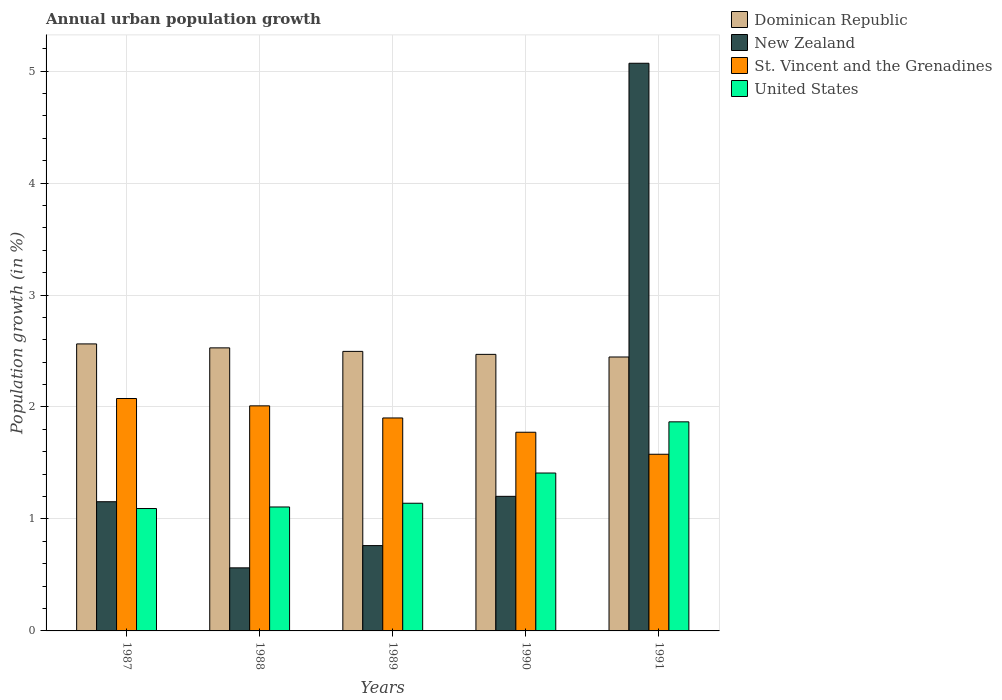How many different coloured bars are there?
Make the answer very short. 4. Are the number of bars per tick equal to the number of legend labels?
Your answer should be very brief. Yes. How many bars are there on the 4th tick from the right?
Your answer should be compact. 4. What is the label of the 2nd group of bars from the left?
Give a very brief answer. 1988. In how many cases, is the number of bars for a given year not equal to the number of legend labels?
Keep it short and to the point. 0. What is the percentage of urban population growth in New Zealand in 1989?
Offer a very short reply. 0.76. Across all years, what is the maximum percentage of urban population growth in Dominican Republic?
Provide a succinct answer. 2.56. Across all years, what is the minimum percentage of urban population growth in United States?
Provide a succinct answer. 1.09. What is the total percentage of urban population growth in Dominican Republic in the graph?
Provide a succinct answer. 12.51. What is the difference between the percentage of urban population growth in St. Vincent and the Grenadines in 1988 and that in 1990?
Ensure brevity in your answer.  0.24. What is the difference between the percentage of urban population growth in St. Vincent and the Grenadines in 1987 and the percentage of urban population growth in United States in 1991?
Offer a very short reply. 0.21. What is the average percentage of urban population growth in Dominican Republic per year?
Make the answer very short. 2.5. In the year 1988, what is the difference between the percentage of urban population growth in Dominican Republic and percentage of urban population growth in St. Vincent and the Grenadines?
Make the answer very short. 0.52. In how many years, is the percentage of urban population growth in New Zealand greater than 5 %?
Your response must be concise. 1. What is the ratio of the percentage of urban population growth in United States in 1988 to that in 1991?
Your response must be concise. 0.59. Is the difference between the percentage of urban population growth in Dominican Republic in 1988 and 1990 greater than the difference between the percentage of urban population growth in St. Vincent and the Grenadines in 1988 and 1990?
Offer a terse response. No. What is the difference between the highest and the second highest percentage of urban population growth in Dominican Republic?
Make the answer very short. 0.04. What is the difference between the highest and the lowest percentage of urban population growth in Dominican Republic?
Your answer should be compact. 0.12. In how many years, is the percentage of urban population growth in New Zealand greater than the average percentage of urban population growth in New Zealand taken over all years?
Your answer should be very brief. 1. What does the 3rd bar from the left in 1990 represents?
Give a very brief answer. St. Vincent and the Grenadines. What does the 2nd bar from the right in 1987 represents?
Your answer should be compact. St. Vincent and the Grenadines. Is it the case that in every year, the sum of the percentage of urban population growth in St. Vincent and the Grenadines and percentage of urban population growth in New Zealand is greater than the percentage of urban population growth in United States?
Make the answer very short. Yes. How many years are there in the graph?
Offer a very short reply. 5. Are the values on the major ticks of Y-axis written in scientific E-notation?
Your answer should be very brief. No. How are the legend labels stacked?
Provide a succinct answer. Vertical. What is the title of the graph?
Offer a very short reply. Annual urban population growth. What is the label or title of the X-axis?
Your response must be concise. Years. What is the label or title of the Y-axis?
Ensure brevity in your answer.  Population growth (in %). What is the Population growth (in %) of Dominican Republic in 1987?
Your answer should be very brief. 2.56. What is the Population growth (in %) of New Zealand in 1987?
Your answer should be very brief. 1.15. What is the Population growth (in %) of St. Vincent and the Grenadines in 1987?
Make the answer very short. 2.08. What is the Population growth (in %) of United States in 1987?
Give a very brief answer. 1.09. What is the Population growth (in %) of Dominican Republic in 1988?
Offer a very short reply. 2.53. What is the Population growth (in %) in New Zealand in 1988?
Make the answer very short. 0.56. What is the Population growth (in %) of St. Vincent and the Grenadines in 1988?
Make the answer very short. 2.01. What is the Population growth (in %) in United States in 1988?
Give a very brief answer. 1.11. What is the Population growth (in %) in Dominican Republic in 1989?
Make the answer very short. 2.5. What is the Population growth (in %) in New Zealand in 1989?
Ensure brevity in your answer.  0.76. What is the Population growth (in %) of St. Vincent and the Grenadines in 1989?
Ensure brevity in your answer.  1.9. What is the Population growth (in %) of United States in 1989?
Give a very brief answer. 1.14. What is the Population growth (in %) in Dominican Republic in 1990?
Offer a very short reply. 2.47. What is the Population growth (in %) of New Zealand in 1990?
Offer a very short reply. 1.2. What is the Population growth (in %) of St. Vincent and the Grenadines in 1990?
Offer a very short reply. 1.77. What is the Population growth (in %) of United States in 1990?
Provide a short and direct response. 1.41. What is the Population growth (in %) of Dominican Republic in 1991?
Give a very brief answer. 2.45. What is the Population growth (in %) in New Zealand in 1991?
Provide a succinct answer. 5.07. What is the Population growth (in %) of St. Vincent and the Grenadines in 1991?
Provide a succinct answer. 1.58. What is the Population growth (in %) in United States in 1991?
Offer a very short reply. 1.87. Across all years, what is the maximum Population growth (in %) of Dominican Republic?
Provide a succinct answer. 2.56. Across all years, what is the maximum Population growth (in %) of New Zealand?
Provide a short and direct response. 5.07. Across all years, what is the maximum Population growth (in %) of St. Vincent and the Grenadines?
Your response must be concise. 2.08. Across all years, what is the maximum Population growth (in %) of United States?
Offer a very short reply. 1.87. Across all years, what is the minimum Population growth (in %) in Dominican Republic?
Make the answer very short. 2.45. Across all years, what is the minimum Population growth (in %) of New Zealand?
Offer a terse response. 0.56. Across all years, what is the minimum Population growth (in %) in St. Vincent and the Grenadines?
Make the answer very short. 1.58. Across all years, what is the minimum Population growth (in %) in United States?
Give a very brief answer. 1.09. What is the total Population growth (in %) of Dominican Republic in the graph?
Offer a terse response. 12.51. What is the total Population growth (in %) of New Zealand in the graph?
Provide a succinct answer. 8.75. What is the total Population growth (in %) in St. Vincent and the Grenadines in the graph?
Ensure brevity in your answer.  9.34. What is the total Population growth (in %) of United States in the graph?
Make the answer very short. 6.62. What is the difference between the Population growth (in %) of Dominican Republic in 1987 and that in 1988?
Offer a very short reply. 0.04. What is the difference between the Population growth (in %) of New Zealand in 1987 and that in 1988?
Make the answer very short. 0.59. What is the difference between the Population growth (in %) of St. Vincent and the Grenadines in 1987 and that in 1988?
Offer a very short reply. 0.07. What is the difference between the Population growth (in %) in United States in 1987 and that in 1988?
Your response must be concise. -0.01. What is the difference between the Population growth (in %) of Dominican Republic in 1987 and that in 1989?
Offer a very short reply. 0.07. What is the difference between the Population growth (in %) of New Zealand in 1987 and that in 1989?
Offer a very short reply. 0.39. What is the difference between the Population growth (in %) in St. Vincent and the Grenadines in 1987 and that in 1989?
Offer a terse response. 0.17. What is the difference between the Population growth (in %) of United States in 1987 and that in 1989?
Provide a succinct answer. -0.05. What is the difference between the Population growth (in %) of Dominican Republic in 1987 and that in 1990?
Provide a succinct answer. 0.09. What is the difference between the Population growth (in %) in New Zealand in 1987 and that in 1990?
Keep it short and to the point. -0.05. What is the difference between the Population growth (in %) in St. Vincent and the Grenadines in 1987 and that in 1990?
Offer a very short reply. 0.3. What is the difference between the Population growth (in %) in United States in 1987 and that in 1990?
Provide a succinct answer. -0.32. What is the difference between the Population growth (in %) in Dominican Republic in 1987 and that in 1991?
Provide a short and direct response. 0.12. What is the difference between the Population growth (in %) in New Zealand in 1987 and that in 1991?
Keep it short and to the point. -3.92. What is the difference between the Population growth (in %) of St. Vincent and the Grenadines in 1987 and that in 1991?
Your answer should be compact. 0.5. What is the difference between the Population growth (in %) in United States in 1987 and that in 1991?
Keep it short and to the point. -0.77. What is the difference between the Population growth (in %) in Dominican Republic in 1988 and that in 1989?
Keep it short and to the point. 0.03. What is the difference between the Population growth (in %) of New Zealand in 1988 and that in 1989?
Your answer should be very brief. -0.2. What is the difference between the Population growth (in %) of St. Vincent and the Grenadines in 1988 and that in 1989?
Keep it short and to the point. 0.11. What is the difference between the Population growth (in %) in United States in 1988 and that in 1989?
Provide a succinct answer. -0.03. What is the difference between the Population growth (in %) in Dominican Republic in 1988 and that in 1990?
Make the answer very short. 0.06. What is the difference between the Population growth (in %) of New Zealand in 1988 and that in 1990?
Give a very brief answer. -0.64. What is the difference between the Population growth (in %) in St. Vincent and the Grenadines in 1988 and that in 1990?
Your answer should be compact. 0.24. What is the difference between the Population growth (in %) in United States in 1988 and that in 1990?
Make the answer very short. -0.3. What is the difference between the Population growth (in %) in Dominican Republic in 1988 and that in 1991?
Make the answer very short. 0.08. What is the difference between the Population growth (in %) in New Zealand in 1988 and that in 1991?
Give a very brief answer. -4.51. What is the difference between the Population growth (in %) of St. Vincent and the Grenadines in 1988 and that in 1991?
Your answer should be very brief. 0.43. What is the difference between the Population growth (in %) in United States in 1988 and that in 1991?
Your answer should be very brief. -0.76. What is the difference between the Population growth (in %) of Dominican Republic in 1989 and that in 1990?
Your answer should be very brief. 0.03. What is the difference between the Population growth (in %) of New Zealand in 1989 and that in 1990?
Your answer should be very brief. -0.44. What is the difference between the Population growth (in %) in St. Vincent and the Grenadines in 1989 and that in 1990?
Keep it short and to the point. 0.13. What is the difference between the Population growth (in %) in United States in 1989 and that in 1990?
Make the answer very short. -0.27. What is the difference between the Population growth (in %) in Dominican Republic in 1989 and that in 1991?
Your response must be concise. 0.05. What is the difference between the Population growth (in %) in New Zealand in 1989 and that in 1991?
Your response must be concise. -4.31. What is the difference between the Population growth (in %) of St. Vincent and the Grenadines in 1989 and that in 1991?
Provide a short and direct response. 0.32. What is the difference between the Population growth (in %) of United States in 1989 and that in 1991?
Give a very brief answer. -0.73. What is the difference between the Population growth (in %) in Dominican Republic in 1990 and that in 1991?
Give a very brief answer. 0.02. What is the difference between the Population growth (in %) in New Zealand in 1990 and that in 1991?
Offer a very short reply. -3.87. What is the difference between the Population growth (in %) of St. Vincent and the Grenadines in 1990 and that in 1991?
Provide a succinct answer. 0.2. What is the difference between the Population growth (in %) of United States in 1990 and that in 1991?
Provide a short and direct response. -0.46. What is the difference between the Population growth (in %) of Dominican Republic in 1987 and the Population growth (in %) of New Zealand in 1988?
Offer a terse response. 2. What is the difference between the Population growth (in %) of Dominican Republic in 1987 and the Population growth (in %) of St. Vincent and the Grenadines in 1988?
Make the answer very short. 0.55. What is the difference between the Population growth (in %) in Dominican Republic in 1987 and the Population growth (in %) in United States in 1988?
Offer a terse response. 1.46. What is the difference between the Population growth (in %) of New Zealand in 1987 and the Population growth (in %) of St. Vincent and the Grenadines in 1988?
Keep it short and to the point. -0.86. What is the difference between the Population growth (in %) in New Zealand in 1987 and the Population growth (in %) in United States in 1988?
Keep it short and to the point. 0.05. What is the difference between the Population growth (in %) of St. Vincent and the Grenadines in 1987 and the Population growth (in %) of United States in 1988?
Your answer should be compact. 0.97. What is the difference between the Population growth (in %) of Dominican Republic in 1987 and the Population growth (in %) of New Zealand in 1989?
Make the answer very short. 1.8. What is the difference between the Population growth (in %) of Dominican Republic in 1987 and the Population growth (in %) of St. Vincent and the Grenadines in 1989?
Your answer should be very brief. 0.66. What is the difference between the Population growth (in %) of Dominican Republic in 1987 and the Population growth (in %) of United States in 1989?
Offer a very short reply. 1.42. What is the difference between the Population growth (in %) in New Zealand in 1987 and the Population growth (in %) in St. Vincent and the Grenadines in 1989?
Your answer should be compact. -0.75. What is the difference between the Population growth (in %) of New Zealand in 1987 and the Population growth (in %) of United States in 1989?
Provide a succinct answer. 0.01. What is the difference between the Population growth (in %) in St. Vincent and the Grenadines in 1987 and the Population growth (in %) in United States in 1989?
Your response must be concise. 0.94. What is the difference between the Population growth (in %) in Dominican Republic in 1987 and the Population growth (in %) in New Zealand in 1990?
Offer a very short reply. 1.36. What is the difference between the Population growth (in %) of Dominican Republic in 1987 and the Population growth (in %) of St. Vincent and the Grenadines in 1990?
Make the answer very short. 0.79. What is the difference between the Population growth (in %) in Dominican Republic in 1987 and the Population growth (in %) in United States in 1990?
Make the answer very short. 1.15. What is the difference between the Population growth (in %) of New Zealand in 1987 and the Population growth (in %) of St. Vincent and the Grenadines in 1990?
Give a very brief answer. -0.62. What is the difference between the Population growth (in %) in New Zealand in 1987 and the Population growth (in %) in United States in 1990?
Your answer should be compact. -0.26. What is the difference between the Population growth (in %) of St. Vincent and the Grenadines in 1987 and the Population growth (in %) of United States in 1990?
Provide a short and direct response. 0.67. What is the difference between the Population growth (in %) in Dominican Republic in 1987 and the Population growth (in %) in New Zealand in 1991?
Your answer should be very brief. -2.51. What is the difference between the Population growth (in %) in Dominican Republic in 1987 and the Population growth (in %) in St. Vincent and the Grenadines in 1991?
Your answer should be compact. 0.99. What is the difference between the Population growth (in %) of Dominican Republic in 1987 and the Population growth (in %) of United States in 1991?
Your response must be concise. 0.7. What is the difference between the Population growth (in %) in New Zealand in 1987 and the Population growth (in %) in St. Vincent and the Grenadines in 1991?
Offer a very short reply. -0.42. What is the difference between the Population growth (in %) of New Zealand in 1987 and the Population growth (in %) of United States in 1991?
Keep it short and to the point. -0.71. What is the difference between the Population growth (in %) of St. Vincent and the Grenadines in 1987 and the Population growth (in %) of United States in 1991?
Make the answer very short. 0.21. What is the difference between the Population growth (in %) in Dominican Republic in 1988 and the Population growth (in %) in New Zealand in 1989?
Your answer should be compact. 1.77. What is the difference between the Population growth (in %) in Dominican Republic in 1988 and the Population growth (in %) in St. Vincent and the Grenadines in 1989?
Provide a short and direct response. 0.63. What is the difference between the Population growth (in %) of Dominican Republic in 1988 and the Population growth (in %) of United States in 1989?
Offer a very short reply. 1.39. What is the difference between the Population growth (in %) in New Zealand in 1988 and the Population growth (in %) in St. Vincent and the Grenadines in 1989?
Keep it short and to the point. -1.34. What is the difference between the Population growth (in %) in New Zealand in 1988 and the Population growth (in %) in United States in 1989?
Your answer should be very brief. -0.58. What is the difference between the Population growth (in %) of St. Vincent and the Grenadines in 1988 and the Population growth (in %) of United States in 1989?
Your answer should be very brief. 0.87. What is the difference between the Population growth (in %) in Dominican Republic in 1988 and the Population growth (in %) in New Zealand in 1990?
Your answer should be compact. 1.33. What is the difference between the Population growth (in %) of Dominican Republic in 1988 and the Population growth (in %) of St. Vincent and the Grenadines in 1990?
Your answer should be very brief. 0.75. What is the difference between the Population growth (in %) in Dominican Republic in 1988 and the Population growth (in %) in United States in 1990?
Keep it short and to the point. 1.12. What is the difference between the Population growth (in %) of New Zealand in 1988 and the Population growth (in %) of St. Vincent and the Grenadines in 1990?
Your answer should be compact. -1.21. What is the difference between the Population growth (in %) in New Zealand in 1988 and the Population growth (in %) in United States in 1990?
Make the answer very short. -0.85. What is the difference between the Population growth (in %) in Dominican Republic in 1988 and the Population growth (in %) in New Zealand in 1991?
Provide a short and direct response. -2.54. What is the difference between the Population growth (in %) in Dominican Republic in 1988 and the Population growth (in %) in St. Vincent and the Grenadines in 1991?
Ensure brevity in your answer.  0.95. What is the difference between the Population growth (in %) in Dominican Republic in 1988 and the Population growth (in %) in United States in 1991?
Keep it short and to the point. 0.66. What is the difference between the Population growth (in %) of New Zealand in 1988 and the Population growth (in %) of St. Vincent and the Grenadines in 1991?
Your response must be concise. -1.01. What is the difference between the Population growth (in %) of New Zealand in 1988 and the Population growth (in %) of United States in 1991?
Provide a succinct answer. -1.3. What is the difference between the Population growth (in %) of St. Vincent and the Grenadines in 1988 and the Population growth (in %) of United States in 1991?
Offer a terse response. 0.14. What is the difference between the Population growth (in %) of Dominican Republic in 1989 and the Population growth (in %) of New Zealand in 1990?
Keep it short and to the point. 1.29. What is the difference between the Population growth (in %) in Dominican Republic in 1989 and the Population growth (in %) in St. Vincent and the Grenadines in 1990?
Your answer should be compact. 0.72. What is the difference between the Population growth (in %) of Dominican Republic in 1989 and the Population growth (in %) of United States in 1990?
Give a very brief answer. 1.09. What is the difference between the Population growth (in %) in New Zealand in 1989 and the Population growth (in %) in St. Vincent and the Grenadines in 1990?
Offer a very short reply. -1.01. What is the difference between the Population growth (in %) of New Zealand in 1989 and the Population growth (in %) of United States in 1990?
Ensure brevity in your answer.  -0.65. What is the difference between the Population growth (in %) in St. Vincent and the Grenadines in 1989 and the Population growth (in %) in United States in 1990?
Offer a terse response. 0.49. What is the difference between the Population growth (in %) of Dominican Republic in 1989 and the Population growth (in %) of New Zealand in 1991?
Your answer should be very brief. -2.57. What is the difference between the Population growth (in %) in Dominican Republic in 1989 and the Population growth (in %) in St. Vincent and the Grenadines in 1991?
Your response must be concise. 0.92. What is the difference between the Population growth (in %) in Dominican Republic in 1989 and the Population growth (in %) in United States in 1991?
Offer a terse response. 0.63. What is the difference between the Population growth (in %) of New Zealand in 1989 and the Population growth (in %) of St. Vincent and the Grenadines in 1991?
Offer a very short reply. -0.82. What is the difference between the Population growth (in %) of New Zealand in 1989 and the Population growth (in %) of United States in 1991?
Offer a terse response. -1.11. What is the difference between the Population growth (in %) in St. Vincent and the Grenadines in 1989 and the Population growth (in %) in United States in 1991?
Your response must be concise. 0.03. What is the difference between the Population growth (in %) in Dominican Republic in 1990 and the Population growth (in %) in New Zealand in 1991?
Your answer should be very brief. -2.6. What is the difference between the Population growth (in %) of Dominican Republic in 1990 and the Population growth (in %) of St. Vincent and the Grenadines in 1991?
Offer a very short reply. 0.89. What is the difference between the Population growth (in %) of Dominican Republic in 1990 and the Population growth (in %) of United States in 1991?
Provide a succinct answer. 0.6. What is the difference between the Population growth (in %) of New Zealand in 1990 and the Population growth (in %) of St. Vincent and the Grenadines in 1991?
Your answer should be compact. -0.38. What is the difference between the Population growth (in %) in New Zealand in 1990 and the Population growth (in %) in United States in 1991?
Your answer should be compact. -0.67. What is the difference between the Population growth (in %) of St. Vincent and the Grenadines in 1990 and the Population growth (in %) of United States in 1991?
Offer a very short reply. -0.09. What is the average Population growth (in %) in Dominican Republic per year?
Your answer should be very brief. 2.5. What is the average Population growth (in %) of New Zealand per year?
Offer a very short reply. 1.75. What is the average Population growth (in %) in St. Vincent and the Grenadines per year?
Your answer should be compact. 1.87. What is the average Population growth (in %) in United States per year?
Keep it short and to the point. 1.32. In the year 1987, what is the difference between the Population growth (in %) of Dominican Republic and Population growth (in %) of New Zealand?
Provide a succinct answer. 1.41. In the year 1987, what is the difference between the Population growth (in %) of Dominican Republic and Population growth (in %) of St. Vincent and the Grenadines?
Your response must be concise. 0.49. In the year 1987, what is the difference between the Population growth (in %) of Dominican Republic and Population growth (in %) of United States?
Ensure brevity in your answer.  1.47. In the year 1987, what is the difference between the Population growth (in %) in New Zealand and Population growth (in %) in St. Vincent and the Grenadines?
Provide a short and direct response. -0.92. In the year 1987, what is the difference between the Population growth (in %) in New Zealand and Population growth (in %) in United States?
Offer a very short reply. 0.06. In the year 1987, what is the difference between the Population growth (in %) of St. Vincent and the Grenadines and Population growth (in %) of United States?
Provide a short and direct response. 0.98. In the year 1988, what is the difference between the Population growth (in %) of Dominican Republic and Population growth (in %) of New Zealand?
Your response must be concise. 1.96. In the year 1988, what is the difference between the Population growth (in %) in Dominican Republic and Population growth (in %) in St. Vincent and the Grenadines?
Your answer should be compact. 0.52. In the year 1988, what is the difference between the Population growth (in %) of Dominican Republic and Population growth (in %) of United States?
Offer a terse response. 1.42. In the year 1988, what is the difference between the Population growth (in %) in New Zealand and Population growth (in %) in St. Vincent and the Grenadines?
Offer a terse response. -1.45. In the year 1988, what is the difference between the Population growth (in %) in New Zealand and Population growth (in %) in United States?
Your answer should be compact. -0.54. In the year 1988, what is the difference between the Population growth (in %) of St. Vincent and the Grenadines and Population growth (in %) of United States?
Give a very brief answer. 0.9. In the year 1989, what is the difference between the Population growth (in %) in Dominican Republic and Population growth (in %) in New Zealand?
Provide a succinct answer. 1.73. In the year 1989, what is the difference between the Population growth (in %) of Dominican Republic and Population growth (in %) of St. Vincent and the Grenadines?
Your response must be concise. 0.59. In the year 1989, what is the difference between the Population growth (in %) in Dominican Republic and Population growth (in %) in United States?
Your answer should be very brief. 1.36. In the year 1989, what is the difference between the Population growth (in %) in New Zealand and Population growth (in %) in St. Vincent and the Grenadines?
Your response must be concise. -1.14. In the year 1989, what is the difference between the Population growth (in %) of New Zealand and Population growth (in %) of United States?
Make the answer very short. -0.38. In the year 1989, what is the difference between the Population growth (in %) of St. Vincent and the Grenadines and Population growth (in %) of United States?
Give a very brief answer. 0.76. In the year 1990, what is the difference between the Population growth (in %) of Dominican Republic and Population growth (in %) of New Zealand?
Provide a succinct answer. 1.27. In the year 1990, what is the difference between the Population growth (in %) in Dominican Republic and Population growth (in %) in St. Vincent and the Grenadines?
Keep it short and to the point. 0.7. In the year 1990, what is the difference between the Population growth (in %) in Dominican Republic and Population growth (in %) in United States?
Provide a short and direct response. 1.06. In the year 1990, what is the difference between the Population growth (in %) of New Zealand and Population growth (in %) of St. Vincent and the Grenadines?
Offer a terse response. -0.57. In the year 1990, what is the difference between the Population growth (in %) in New Zealand and Population growth (in %) in United States?
Offer a very short reply. -0.21. In the year 1990, what is the difference between the Population growth (in %) of St. Vincent and the Grenadines and Population growth (in %) of United States?
Provide a succinct answer. 0.36. In the year 1991, what is the difference between the Population growth (in %) in Dominican Republic and Population growth (in %) in New Zealand?
Make the answer very short. -2.62. In the year 1991, what is the difference between the Population growth (in %) in Dominican Republic and Population growth (in %) in St. Vincent and the Grenadines?
Offer a terse response. 0.87. In the year 1991, what is the difference between the Population growth (in %) of Dominican Republic and Population growth (in %) of United States?
Your answer should be compact. 0.58. In the year 1991, what is the difference between the Population growth (in %) of New Zealand and Population growth (in %) of St. Vincent and the Grenadines?
Your answer should be compact. 3.49. In the year 1991, what is the difference between the Population growth (in %) of New Zealand and Population growth (in %) of United States?
Keep it short and to the point. 3.2. In the year 1991, what is the difference between the Population growth (in %) of St. Vincent and the Grenadines and Population growth (in %) of United States?
Offer a very short reply. -0.29. What is the ratio of the Population growth (in %) of New Zealand in 1987 to that in 1988?
Ensure brevity in your answer.  2.05. What is the ratio of the Population growth (in %) of St. Vincent and the Grenadines in 1987 to that in 1988?
Provide a succinct answer. 1.03. What is the ratio of the Population growth (in %) in United States in 1987 to that in 1988?
Ensure brevity in your answer.  0.99. What is the ratio of the Population growth (in %) in Dominican Republic in 1987 to that in 1989?
Your response must be concise. 1.03. What is the ratio of the Population growth (in %) in New Zealand in 1987 to that in 1989?
Your answer should be very brief. 1.51. What is the ratio of the Population growth (in %) of St. Vincent and the Grenadines in 1987 to that in 1989?
Keep it short and to the point. 1.09. What is the ratio of the Population growth (in %) of United States in 1987 to that in 1989?
Keep it short and to the point. 0.96. What is the ratio of the Population growth (in %) of Dominican Republic in 1987 to that in 1990?
Make the answer very short. 1.04. What is the ratio of the Population growth (in %) of New Zealand in 1987 to that in 1990?
Keep it short and to the point. 0.96. What is the ratio of the Population growth (in %) of St. Vincent and the Grenadines in 1987 to that in 1990?
Ensure brevity in your answer.  1.17. What is the ratio of the Population growth (in %) in United States in 1987 to that in 1990?
Make the answer very short. 0.78. What is the ratio of the Population growth (in %) of Dominican Republic in 1987 to that in 1991?
Provide a short and direct response. 1.05. What is the ratio of the Population growth (in %) in New Zealand in 1987 to that in 1991?
Your response must be concise. 0.23. What is the ratio of the Population growth (in %) in St. Vincent and the Grenadines in 1987 to that in 1991?
Provide a short and direct response. 1.32. What is the ratio of the Population growth (in %) in United States in 1987 to that in 1991?
Make the answer very short. 0.59. What is the ratio of the Population growth (in %) in Dominican Republic in 1988 to that in 1989?
Give a very brief answer. 1.01. What is the ratio of the Population growth (in %) of New Zealand in 1988 to that in 1989?
Your answer should be very brief. 0.74. What is the ratio of the Population growth (in %) of St. Vincent and the Grenadines in 1988 to that in 1989?
Your answer should be very brief. 1.06. What is the ratio of the Population growth (in %) in United States in 1988 to that in 1989?
Provide a succinct answer. 0.97. What is the ratio of the Population growth (in %) of Dominican Republic in 1988 to that in 1990?
Provide a short and direct response. 1.02. What is the ratio of the Population growth (in %) of New Zealand in 1988 to that in 1990?
Ensure brevity in your answer.  0.47. What is the ratio of the Population growth (in %) in St. Vincent and the Grenadines in 1988 to that in 1990?
Your answer should be very brief. 1.13. What is the ratio of the Population growth (in %) in United States in 1988 to that in 1990?
Ensure brevity in your answer.  0.79. What is the ratio of the Population growth (in %) of St. Vincent and the Grenadines in 1988 to that in 1991?
Give a very brief answer. 1.27. What is the ratio of the Population growth (in %) in United States in 1988 to that in 1991?
Provide a succinct answer. 0.59. What is the ratio of the Population growth (in %) of Dominican Republic in 1989 to that in 1990?
Give a very brief answer. 1.01. What is the ratio of the Population growth (in %) of New Zealand in 1989 to that in 1990?
Offer a very short reply. 0.63. What is the ratio of the Population growth (in %) in St. Vincent and the Grenadines in 1989 to that in 1990?
Ensure brevity in your answer.  1.07. What is the ratio of the Population growth (in %) of United States in 1989 to that in 1990?
Your answer should be very brief. 0.81. What is the ratio of the Population growth (in %) of Dominican Republic in 1989 to that in 1991?
Ensure brevity in your answer.  1.02. What is the ratio of the Population growth (in %) of New Zealand in 1989 to that in 1991?
Make the answer very short. 0.15. What is the ratio of the Population growth (in %) of St. Vincent and the Grenadines in 1989 to that in 1991?
Your answer should be very brief. 1.21. What is the ratio of the Population growth (in %) of United States in 1989 to that in 1991?
Provide a short and direct response. 0.61. What is the ratio of the Population growth (in %) of Dominican Republic in 1990 to that in 1991?
Provide a short and direct response. 1.01. What is the ratio of the Population growth (in %) of New Zealand in 1990 to that in 1991?
Provide a short and direct response. 0.24. What is the ratio of the Population growth (in %) in St. Vincent and the Grenadines in 1990 to that in 1991?
Your response must be concise. 1.12. What is the ratio of the Population growth (in %) in United States in 1990 to that in 1991?
Provide a succinct answer. 0.76. What is the difference between the highest and the second highest Population growth (in %) of Dominican Republic?
Keep it short and to the point. 0.04. What is the difference between the highest and the second highest Population growth (in %) of New Zealand?
Offer a terse response. 3.87. What is the difference between the highest and the second highest Population growth (in %) in St. Vincent and the Grenadines?
Make the answer very short. 0.07. What is the difference between the highest and the second highest Population growth (in %) in United States?
Your answer should be compact. 0.46. What is the difference between the highest and the lowest Population growth (in %) in Dominican Republic?
Offer a terse response. 0.12. What is the difference between the highest and the lowest Population growth (in %) in New Zealand?
Keep it short and to the point. 4.51. What is the difference between the highest and the lowest Population growth (in %) in St. Vincent and the Grenadines?
Your response must be concise. 0.5. What is the difference between the highest and the lowest Population growth (in %) in United States?
Offer a very short reply. 0.77. 